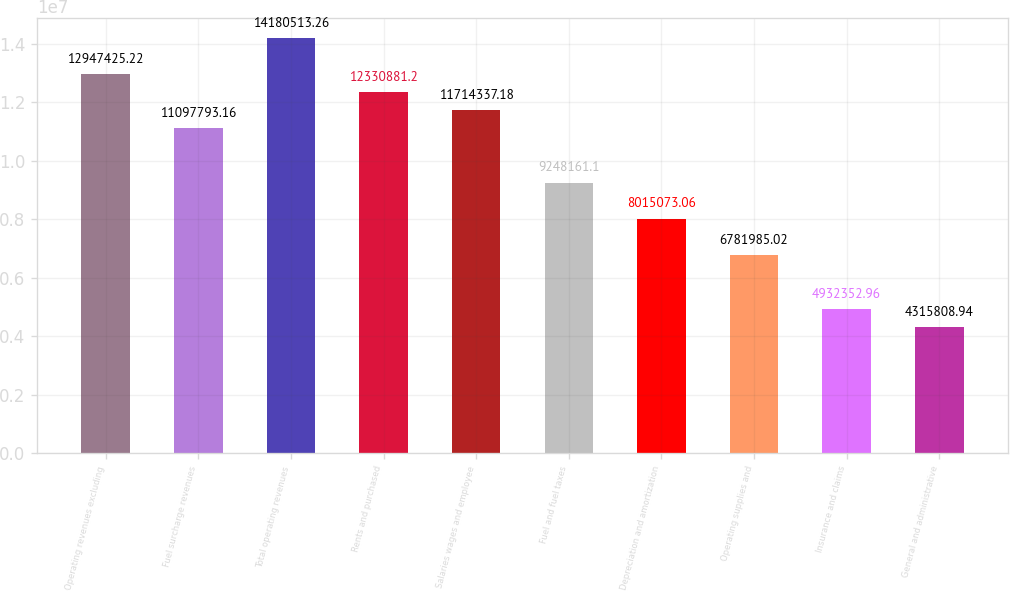Convert chart. <chart><loc_0><loc_0><loc_500><loc_500><bar_chart><fcel>Operating revenues excluding<fcel>Fuel surcharge revenues<fcel>Total operating revenues<fcel>Rents and purchased<fcel>Salaries wages and employee<fcel>Fuel and fuel taxes<fcel>Depreciation and amortization<fcel>Operating supplies and<fcel>Insurance and claims<fcel>General and administrative<nl><fcel>1.29474e+07<fcel>1.10978e+07<fcel>1.41805e+07<fcel>1.23309e+07<fcel>1.17143e+07<fcel>9.24816e+06<fcel>8.01507e+06<fcel>6.78199e+06<fcel>4.93235e+06<fcel>4.31581e+06<nl></chart> 